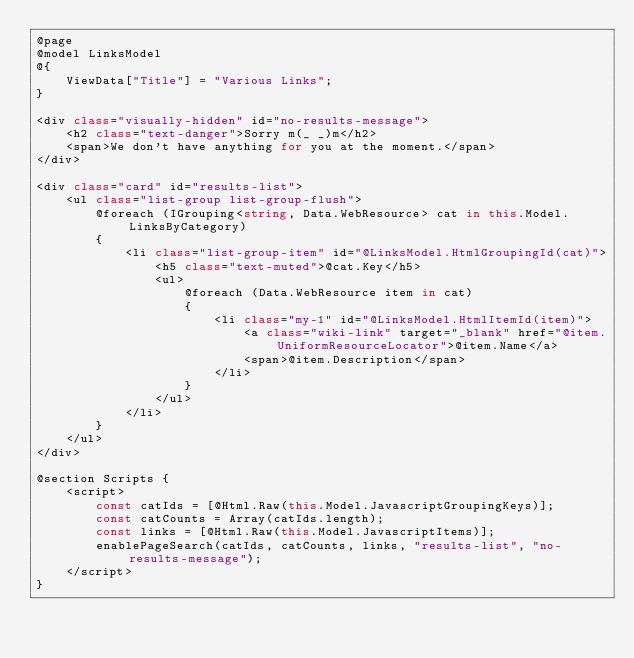Convert code to text. <code><loc_0><loc_0><loc_500><loc_500><_C#_>@page
@model LinksModel
@{
    ViewData["Title"] = "Various Links";
}

<div class="visually-hidden" id="no-results-message">
    <h2 class="text-danger">Sorry m(_ _)m</h2>
    <span>We don't have anything for you at the moment.</span>
</div>

<div class="card" id="results-list">
    <ul class="list-group list-group-flush">
        @foreach (IGrouping<string, Data.WebResource> cat in this.Model.LinksByCategory)
        {
            <li class="list-group-item" id="@LinksModel.HtmlGroupingId(cat)">
                <h5 class="text-muted">@cat.Key</h5>
                <ul>
                    @foreach (Data.WebResource item in cat)
                    {
                        <li class="my-1" id="@LinksModel.HtmlItemId(item)">
                            <a class="wiki-link" target="_blank" href="@item.UniformResourceLocator">@item.Name</a>
                            <span>@item.Description</span>
                        </li>
                    }
                </ul>
            </li>
        }
    </ul>
</div>

@section Scripts {
    <script>
        const catIds = [@Html.Raw(this.Model.JavascriptGroupingKeys)];
        const catCounts = Array(catIds.length);
        const links = [@Html.Raw(this.Model.JavascriptItems)];
        enablePageSearch(catIds, catCounts, links, "results-list", "no-results-message");
    </script>
}
</code> 